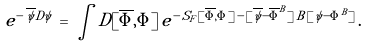Convert formula to latex. <formula><loc_0><loc_0><loc_500><loc_500>e ^ { - \, \overline { \psi } D \psi } \, = \, \int D [ \overline { \Phi } , \Phi ] \, e ^ { - \, S _ { F } [ \overline { \Phi } , \Phi ] \, - \, [ \overline { \psi } - \overline { \Phi } ^ { B } ] \, B \, [ \psi - \Phi ^ { B } ] } \, .</formula> 